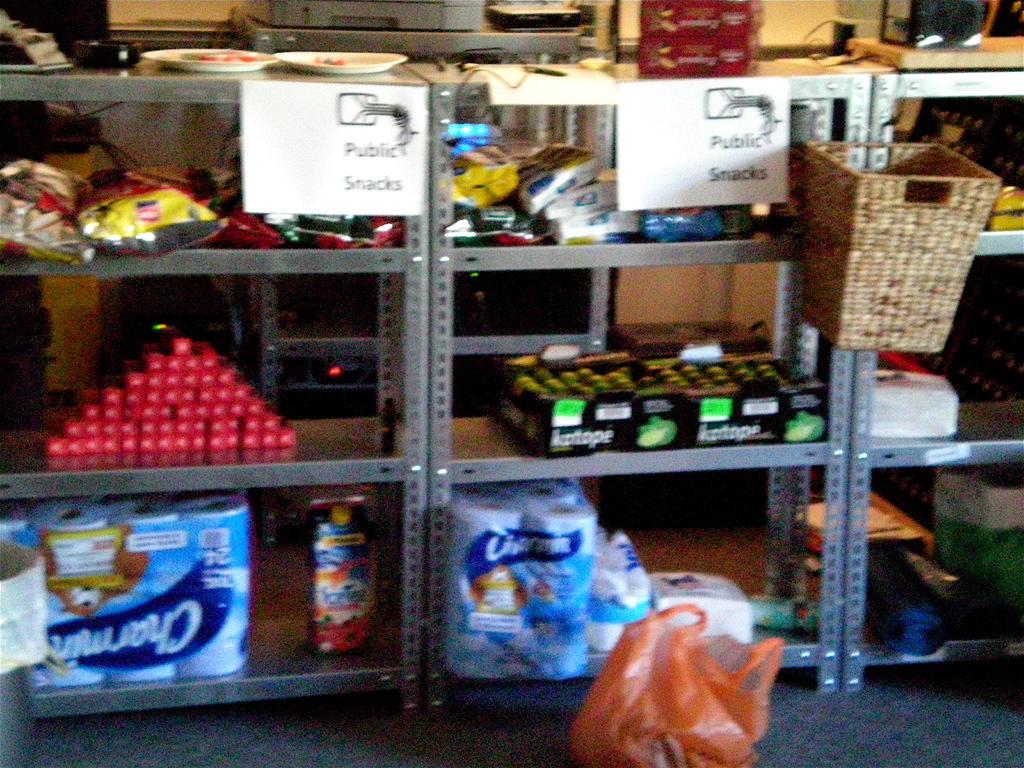What can be seen on the racks in the image? There are objects placed on racks in the image. Can you describe the object on the floor in the image? There is a plastic bag placed on the floor in the image. What type of food can be heard falling during the thunderstorm in the image? There is no food, thunderstorm, or crowd present in the image; it only shows objects on racks and a plastic bag on the floor. 